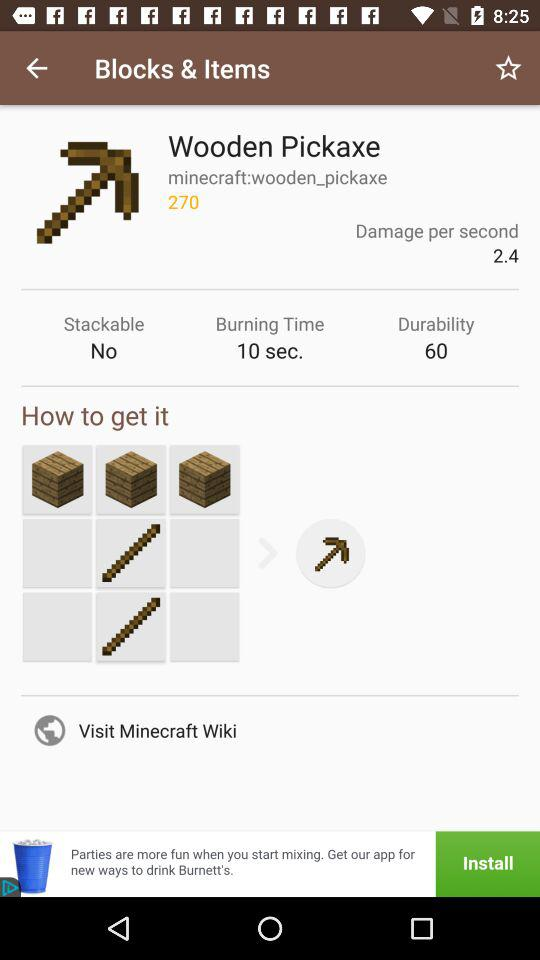How much longer does the wooden pickaxe last than the stick?
Answer the question using a single word or phrase. 60 